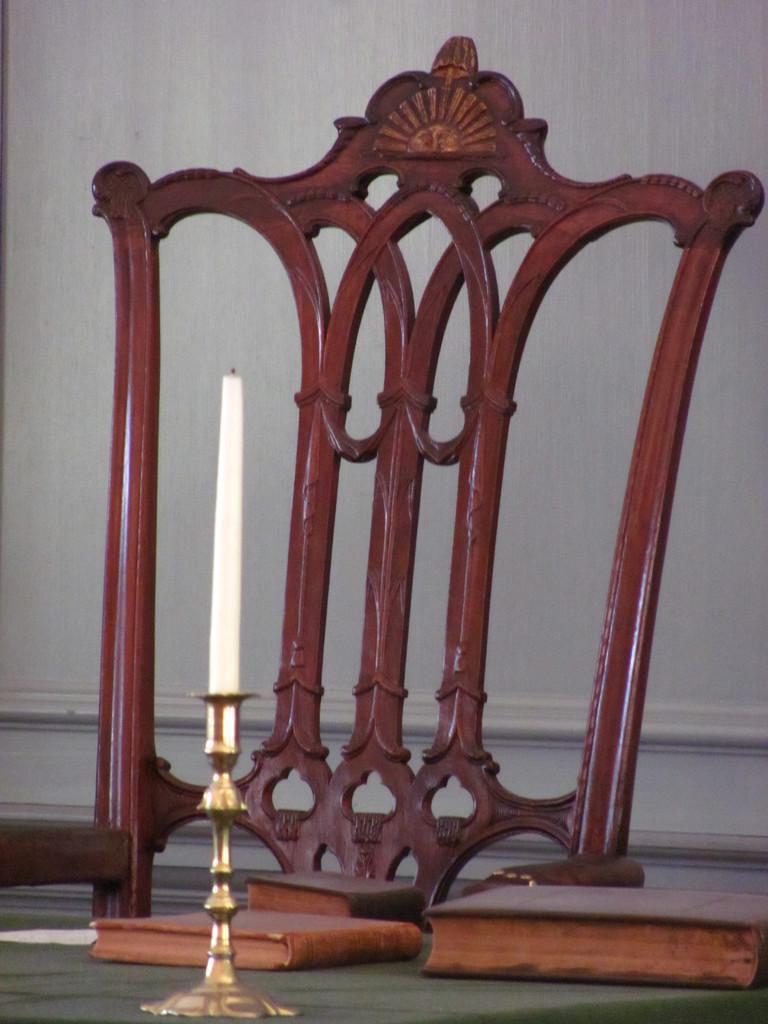Please provide a concise description of this image. In this image there is a chair. Before it there is a table having few books and a candle stand with a candle on it. Background there is a wall. 